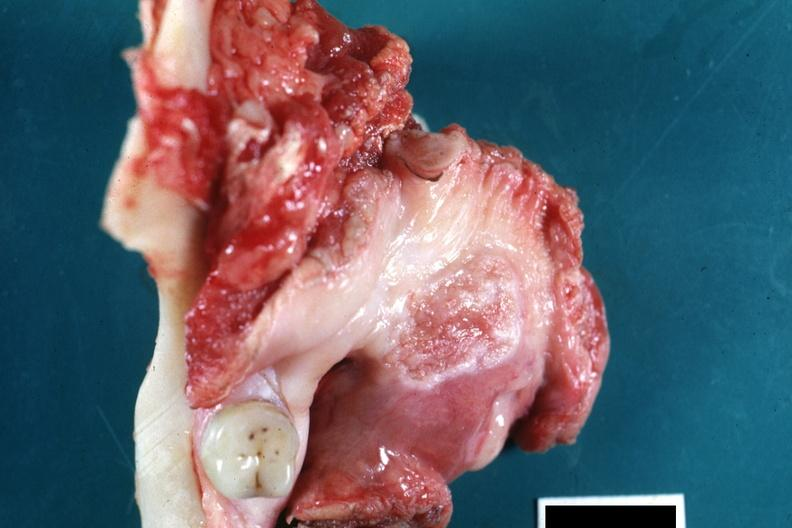s oral present?
Answer the question using a single word or phrase. Yes 